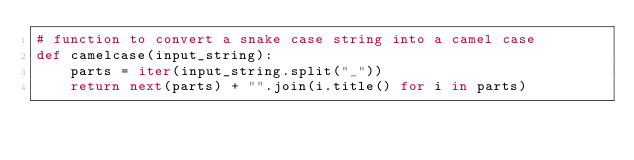Convert code to text. <code><loc_0><loc_0><loc_500><loc_500><_Python_># function to convert a snake case string into a camel case
def camelcase(input_string):
    parts = iter(input_string.split("_"))
    return next(parts) + "".join(i.title() for i in parts)
</code> 